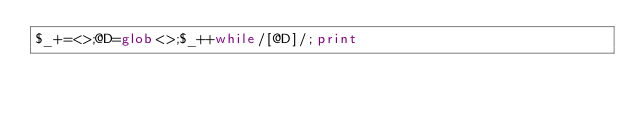Convert code to text. <code><loc_0><loc_0><loc_500><loc_500><_Perl_>$_+=<>;@D=glob<>;$_++while/[@D]/;print</code> 